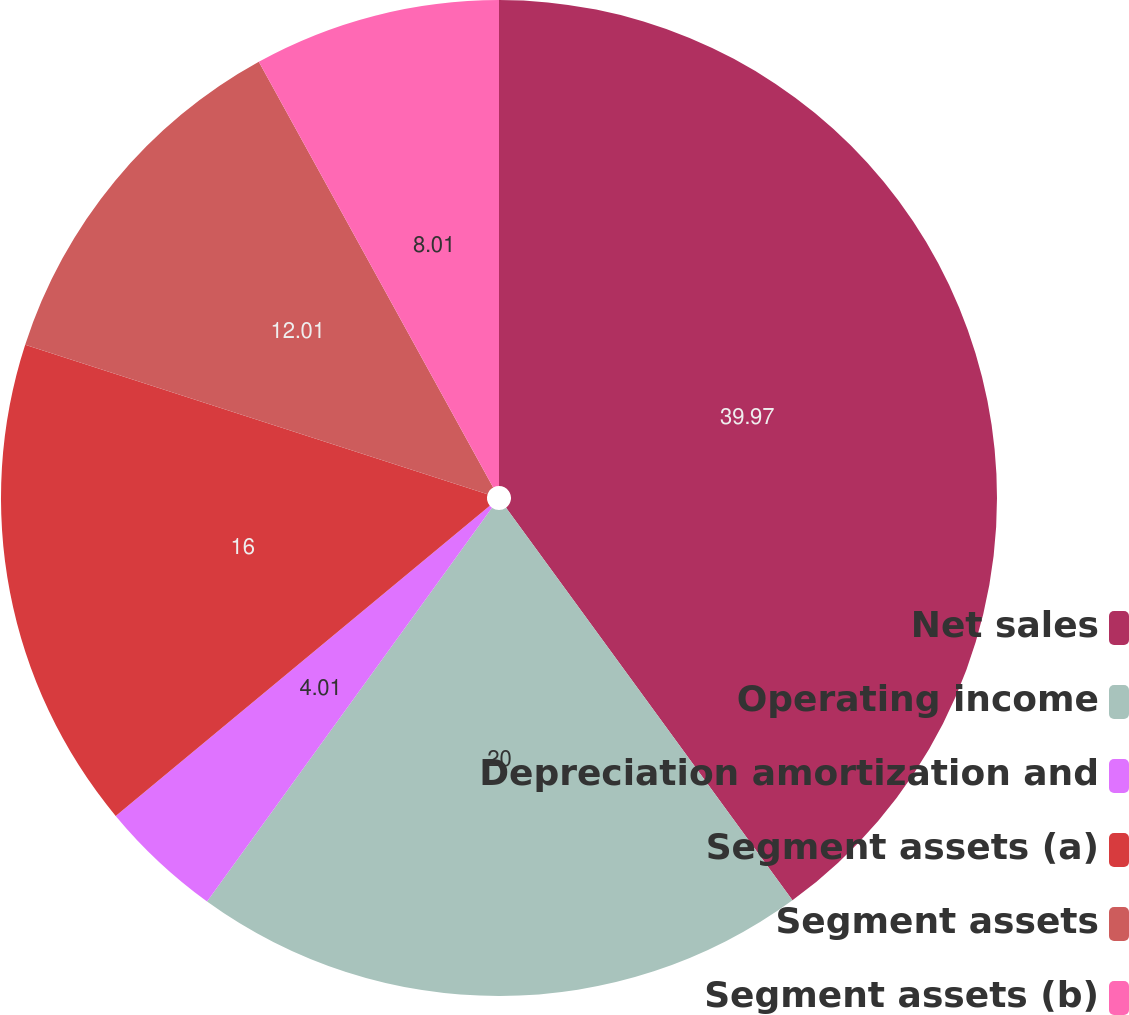Convert chart. <chart><loc_0><loc_0><loc_500><loc_500><pie_chart><fcel>Net sales<fcel>Operating income<fcel>Depreciation amortization and<fcel>Segment assets (a)<fcel>Segment assets<fcel>Segment assets (b)<nl><fcel>39.97%<fcel>20.0%<fcel>4.01%<fcel>16.0%<fcel>12.01%<fcel>8.01%<nl></chart> 